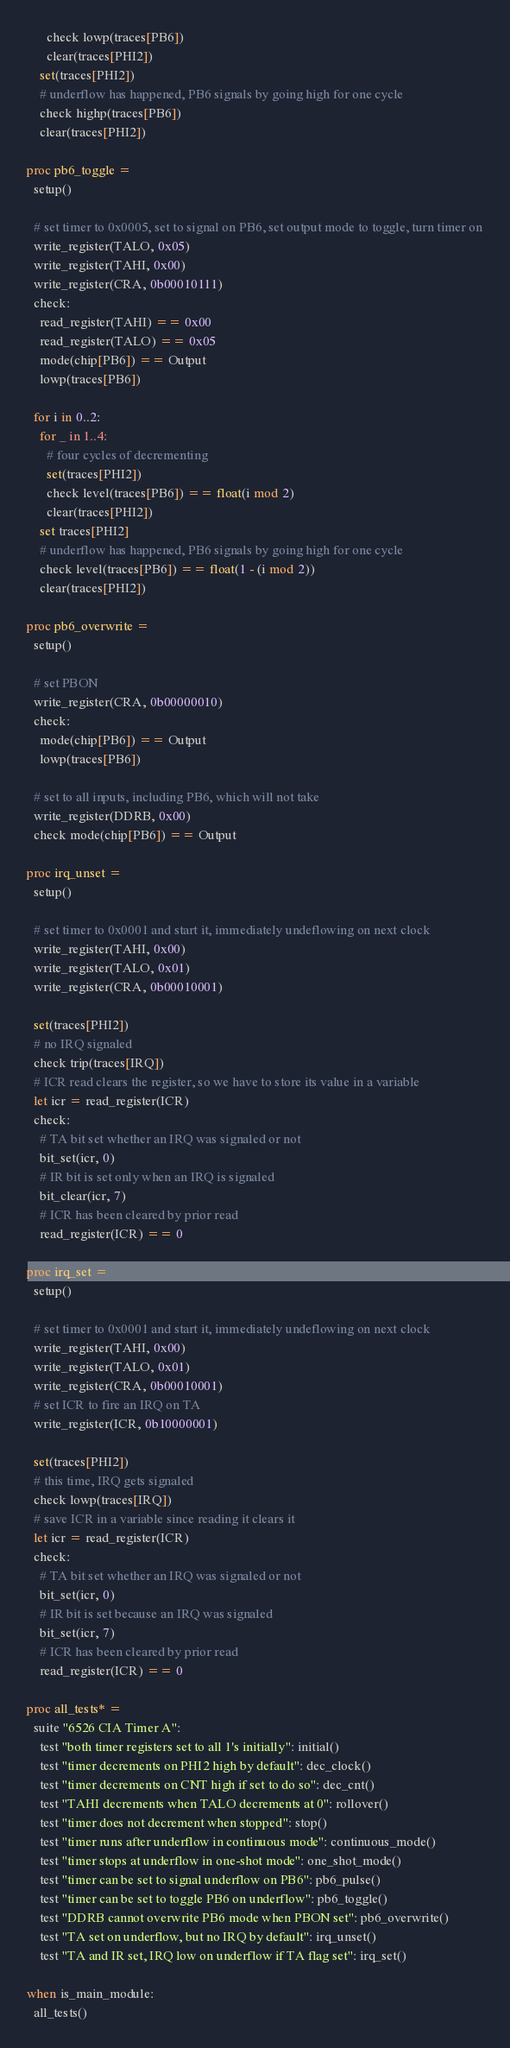Convert code to text. <code><loc_0><loc_0><loc_500><loc_500><_Nim_>      check lowp(traces[PB6])
      clear(traces[PHI2])
    set(traces[PHI2])
    # underflow has happened, PB6 signals by going high for one cycle
    check highp(traces[PB6])
    clear(traces[PHI2])

proc pb6_toggle =
  setup()

  # set timer to 0x0005, set to signal on PB6, set output mode to toggle, turn timer on
  write_register(TALO, 0x05)
  write_register(TAHI, 0x00)
  write_register(CRA, 0b00010111)
  check:
    read_register(TAHI) == 0x00
    read_register(TALO) == 0x05
    mode(chip[PB6]) == Output
    lowp(traces[PB6])
  
  for i in 0..2:
    for _ in 1..4:
      # four cycles of decrementing
      set(traces[PHI2])
      check level(traces[PB6]) == float(i mod 2)
      clear(traces[PHI2])
    set traces[PHI2]
    # underflow has happened, PB6 signals by going high for one cycle
    check level(traces[PB6]) == float(1 - (i mod 2))
    clear(traces[PHI2])

proc pb6_overwrite =
  setup()

  # set PBON
  write_register(CRA, 0b00000010)
  check:
    mode(chip[PB6]) == Output
    lowp(traces[PB6])
  
  # set to all inputs, including PB6, which will not take
  write_register(DDRB, 0x00)
  check mode(chip[PB6]) == Output

proc irq_unset =
  setup()

  # set timer to 0x0001 and start it, immediately undeflowing on next clock
  write_register(TAHI, 0x00)
  write_register(TALO, 0x01)
  write_register(CRA, 0b00010001)

  set(traces[PHI2])
  # no IRQ signaled
  check trip(traces[IRQ])
  # ICR read clears the register, so we have to store its value in a variable
  let icr = read_register(ICR)
  check:
    # TA bit set whether an IRQ was signaled or not
    bit_set(icr, 0)
    # IR bit is set only when an IRQ is signaled
    bit_clear(icr, 7)
    # ICR has been cleared by prior read
    read_register(ICR) == 0

proc irq_set =
  setup()
  
  # set timer to 0x0001 and start it, immediately undeflowing on next clock
  write_register(TAHI, 0x00)
  write_register(TALO, 0x01)
  write_register(CRA, 0b00010001)
  # set ICR to fire an IRQ on TA
  write_register(ICR, 0b10000001)

  set(traces[PHI2])
  # this time, IRQ gets signaled
  check lowp(traces[IRQ])
  # save ICR in a variable since reading it clears it
  let icr = read_register(ICR)
  check:
    # TA bit set whether an IRQ was signaled or not
    bit_set(icr, 0)
    # IR bit is set because an IRQ was signaled
    bit_set(icr, 7)
    # ICR has been cleared by prior read
    read_register(ICR) == 0

proc all_tests* =
  suite "6526 CIA Timer A":
    test "both timer registers set to all 1's initially": initial()
    test "timer decrements on PHI2 high by default": dec_clock()
    test "timer decrements on CNT high if set to do so": dec_cnt()
    test "TAHI decrements when TALO decrements at 0": rollover()
    test "timer does not decrement when stopped": stop()
    test "timer runs after underflow in continuous mode": continuous_mode()
    test "timer stops at underflow in one-shot mode": one_shot_mode()
    test "timer can be set to signal underflow on PB6": pb6_pulse()
    test "timer can be set to toggle PB6 on underflow": pb6_toggle()
    test "DDRB cannot overwrite PB6 mode when PBON set": pb6_overwrite()
    test "TA set on underflow, but no IRQ by default": irq_unset()
    test "TA and IR set, IRQ low on underflow if TA flag set": irq_set()

when is_main_module:
  all_tests()
</code> 